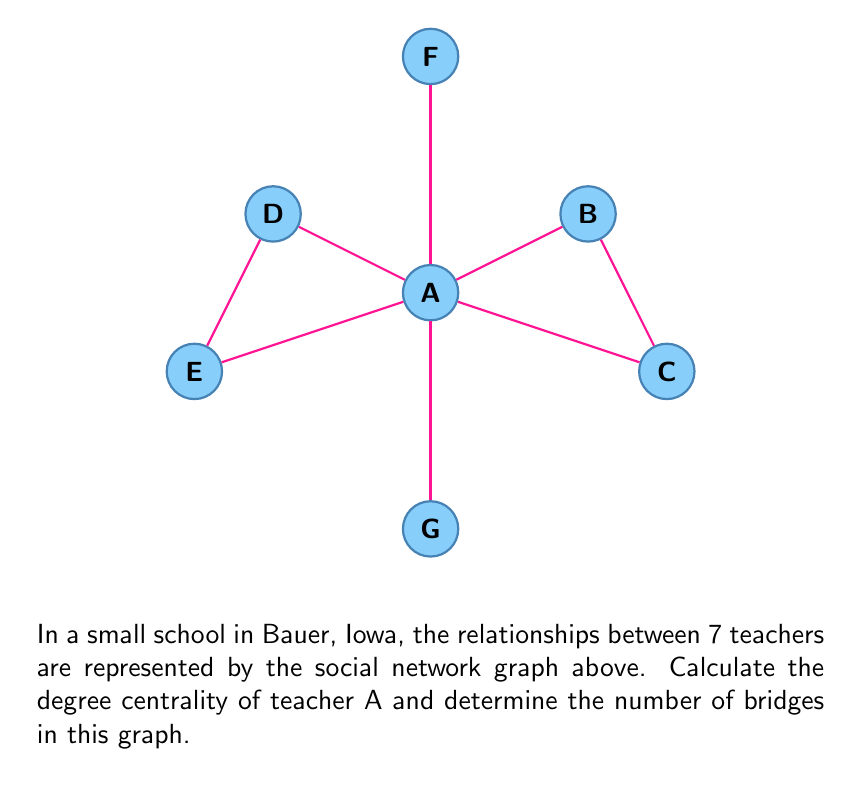Show me your answer to this math problem. Let's approach this problem step-by-step:

1) Degree Centrality:
   The degree centrality of a node is the number of edges connected to it.
   For teacher A, we can count the number of connections:
   A is connected to B, C, D, E, F, and G.
   Therefore, the degree centrality of A is 6.

2) Bridges:
   A bridge is an edge whose removal would disconnect the graph.
   To identify bridges, we need to check each edge:

   - Edge AF: If removed, F would be isolated. This is a bridge.
   - Edge AG: If removed, G would be isolated. This is a bridge.
   - Edge AB: If removed, the graph remains connected. Not a bridge.
   - Edge AC: If removed, the graph remains connected. Not a bridge.
   - Edge AD: If removed, the graph remains connected. Not a bridge.
   - Edge AE: If removed, the graph remains connected. Not a bridge.
   - Edge BC: If removed, the graph remains connected. Not a bridge.
   - Edge DE: If removed, the graph remains connected. Not a bridge.

   In total, there are 2 bridges in this graph.

The degree centrality of A is 6, and the number of bridges is 2.
Answer: Degree centrality of A: 6; Number of bridges: 2 